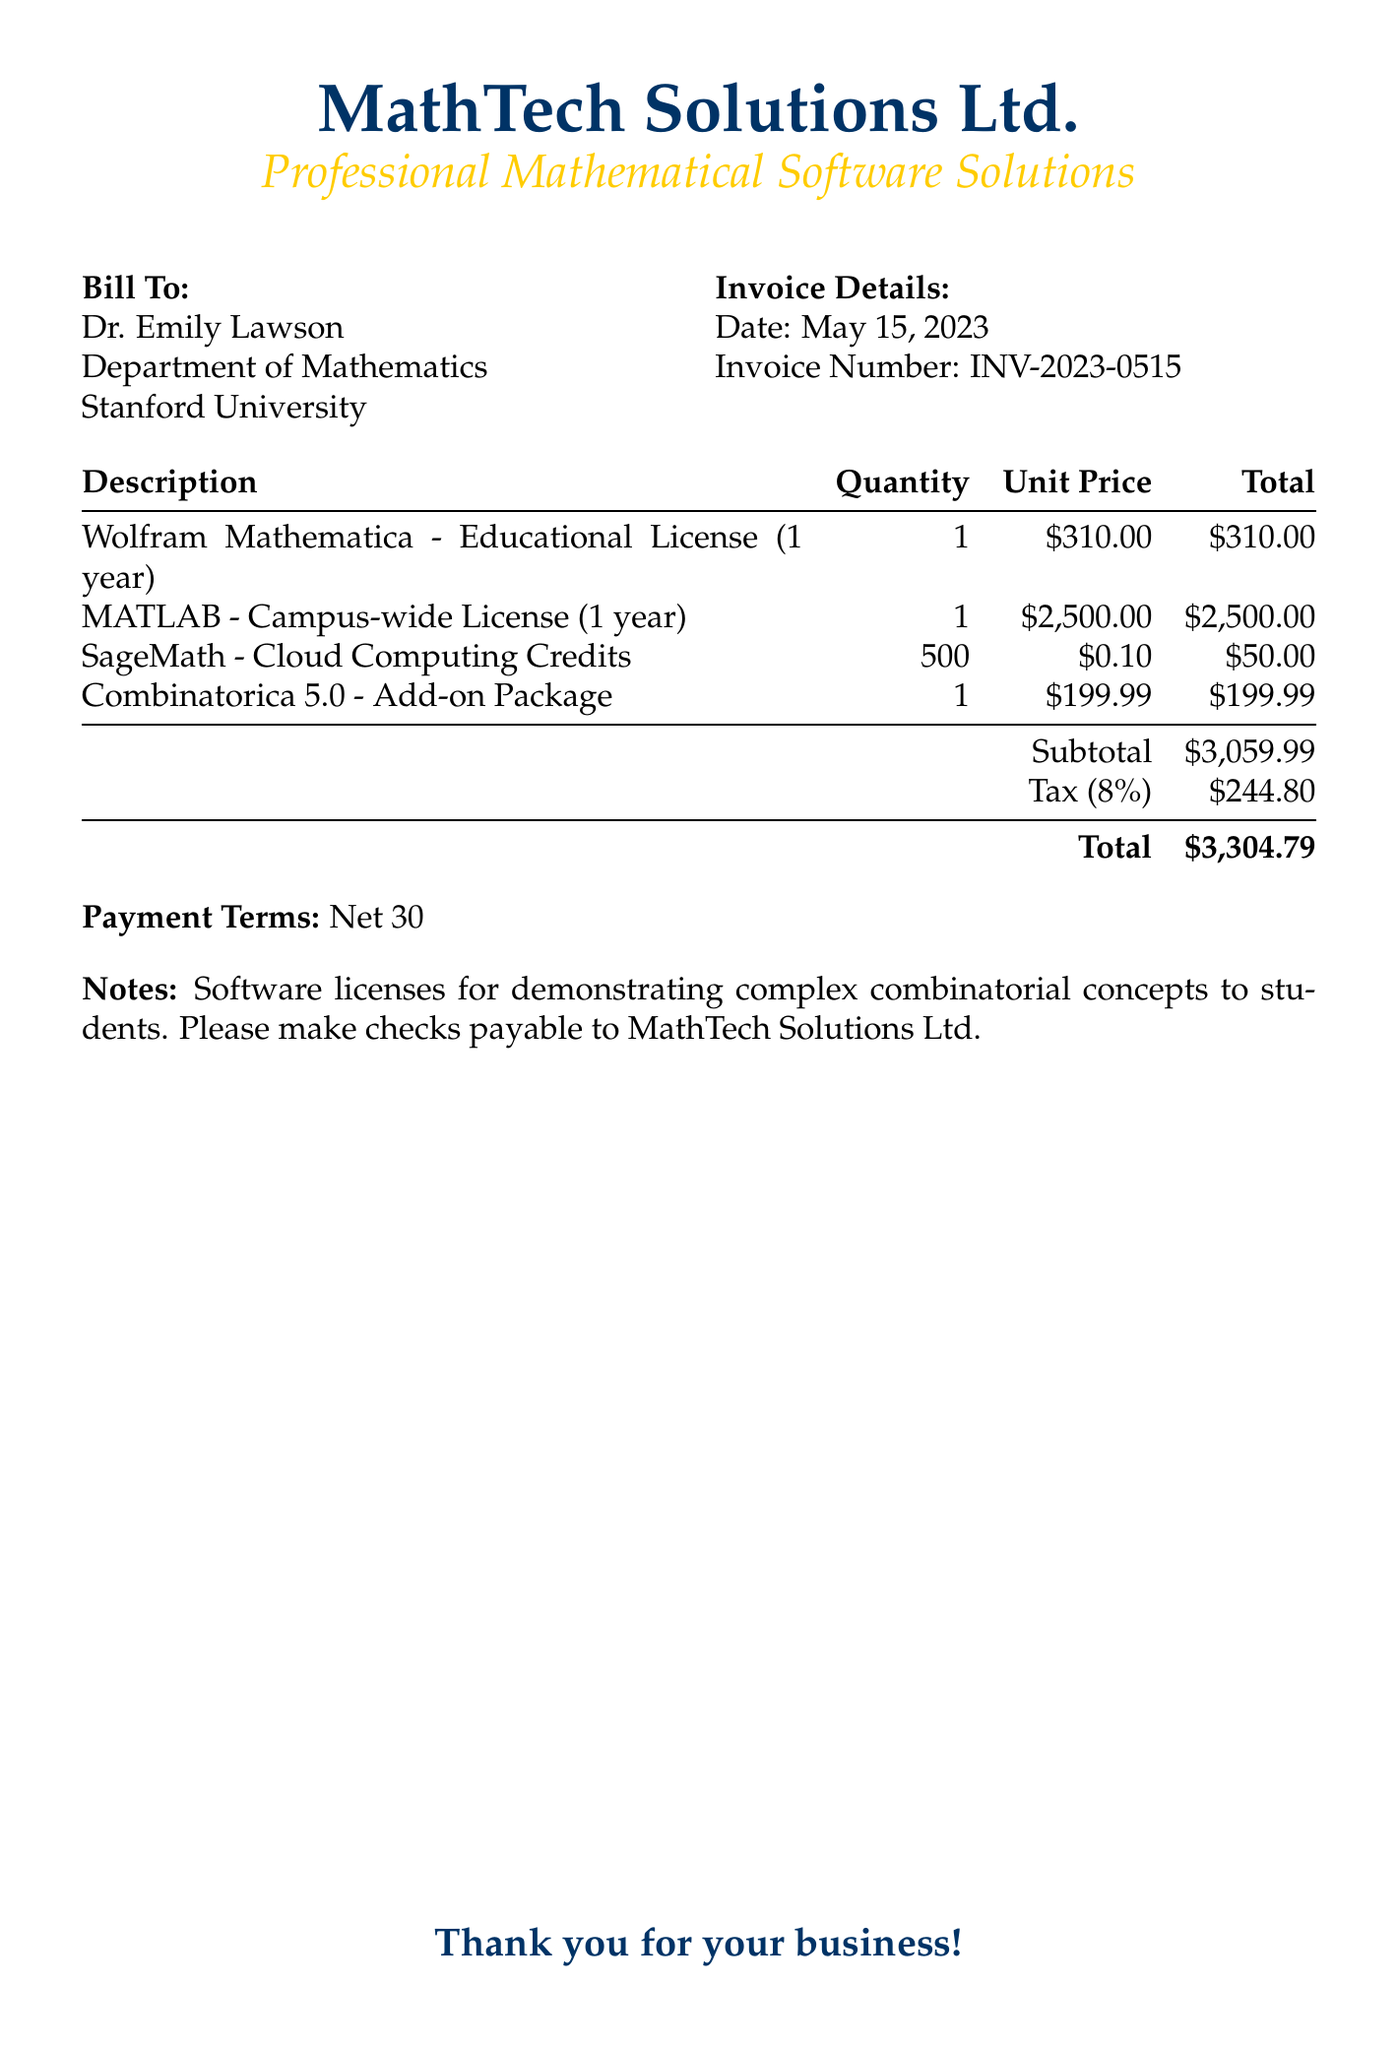What is the invoice number? The invoice number can be found in the invoice details section, listed as INV-2023-0515.
Answer: INV-2023-0515 Who is the recipient of the bill? The recipient of the bill is listed at the top, addressed to Dr. Emily Lawson.
Answer: Dr. Emily Lawson What is the subtotal amount? The subtotal amount is calculated from the total of all items before tax, which is $3,059.99.
Answer: $3,059.99 How much are the cloud computing credits for SageMath? The cost for the cloud computing credits for SageMath can be found in the description section, listed at $0.10 each.
Answer: $0.10 What is the tax percentage applied to the bill? The tax percentage is mentioned directly in the document and is stated to be 8%.
Answer: 8% What is the total amount due? The total amount due is calculated by adding the subtotal and the tax amount, which is $3,304.79.
Answer: $3,304.79 What software package is specifically used for combinatorial concepts? In the notes section, the document states that the software licenses are for demonstrating complex combinatorial concepts.
Answer: Combinatorica 5.0 What are the payment terms specified in the document? The payment terms are written in the document as "Net 30".
Answer: Net 30 What is the date of the invoice? The date of the invoice is indicated in the invoice details section as May 15, 2023.
Answer: May 15, 2023 